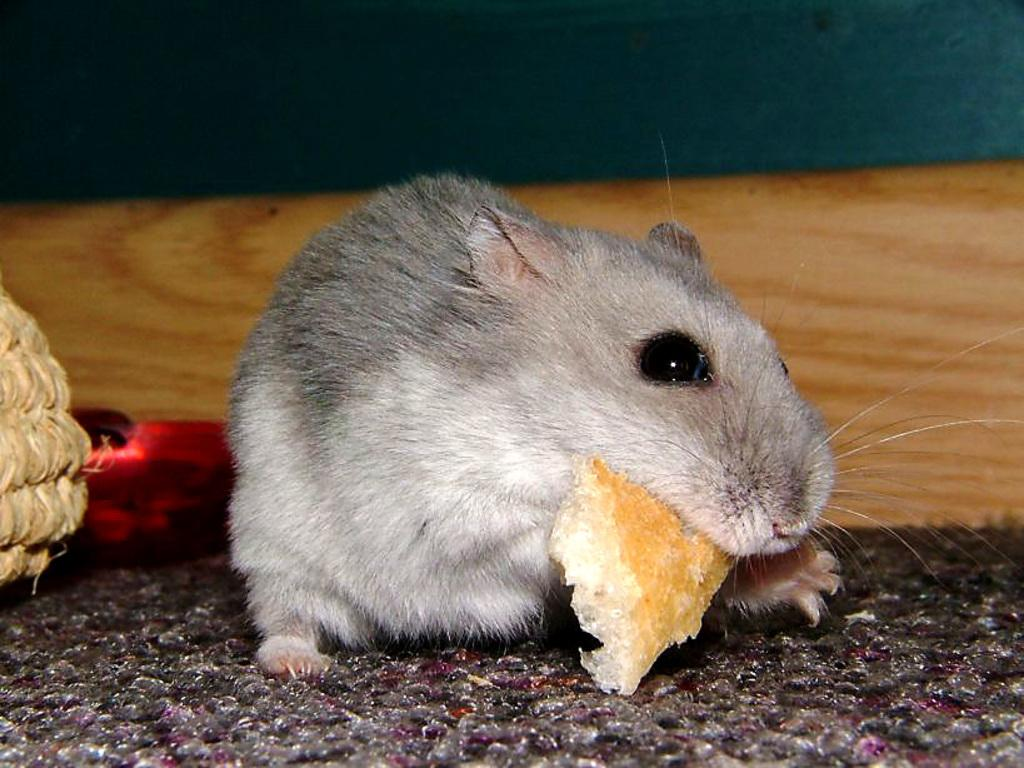What animal is present in the image? There is a rat in the image. What is the rat positioned on in the image? The rat is on a mat. What is the rat holding in the image? The rat is holding a food item. What object is located beside the rat in the image? There is an object beside the rat. What type of mark can be seen on the rat's forehead in the image? There is no mark visible on the rat's forehead in the image. 